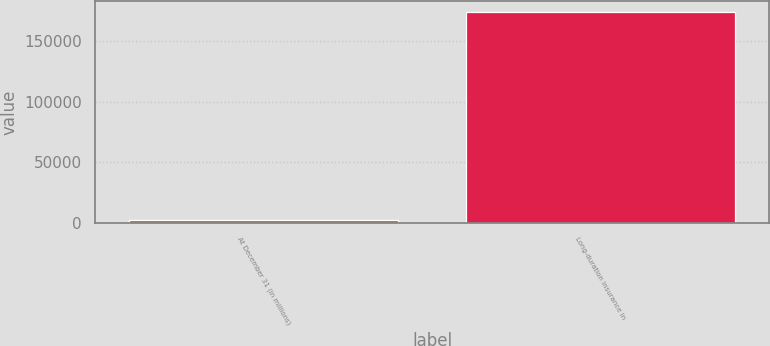Convert chart. <chart><loc_0><loc_0><loc_500><loc_500><bar_chart><fcel>At December 31 (in millions)<fcel>Long-duration insurance in<nl><fcel>2016<fcel>174363<nl></chart> 